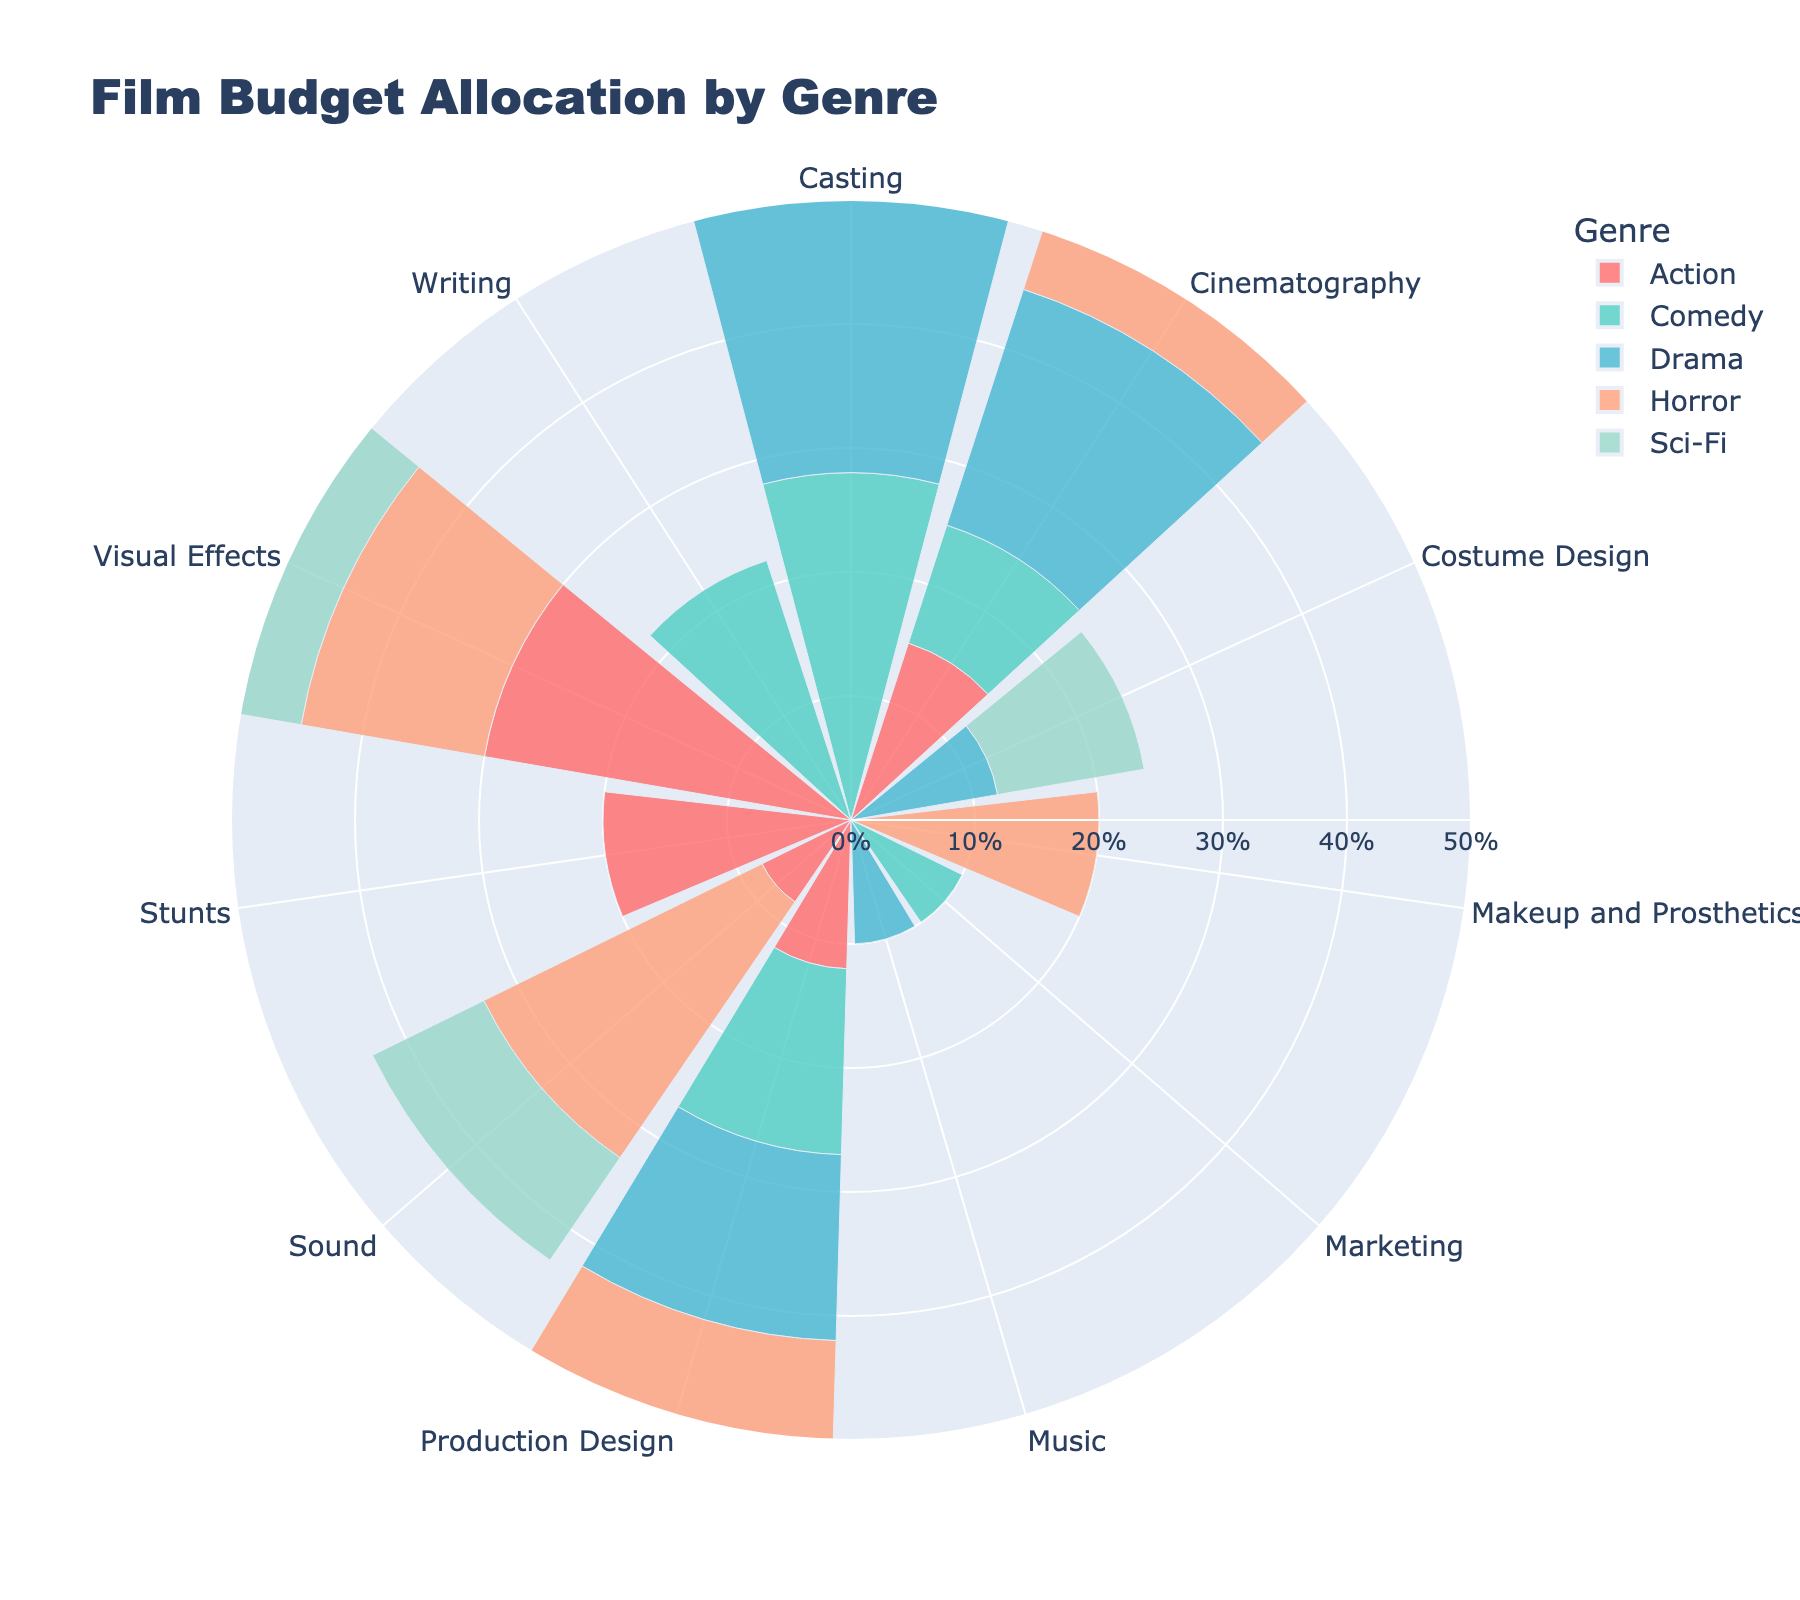What is the title of the plot? The title of the plot is located at the top and describes what the figure represents.
Answer: Film Budget Allocation by Genre How many genres are represented in the plot? The plot utilizes different colors and legends to represent distinct genres. By counting the number of unique legends, we can identify the number of genres.
Answer: 5 Which genre allocates the highest percentage to Visual Effects? The fan chart visually shows the proportion of each department's budget across genres. Find the longest bar in Visual Effects and check its genre via the legend.
Answer: Sci-Fi What is the combined budget percentage for Sound across all genres? To find the combined budget percentage, refer to the Sound department for each genre and sum up the values: Action (8) + Drama (0) + Comedy (0) + Sci-Fi (10) + Horror (25).
Answer: 43% Which genre has the highest percentage for Production Design? Compare the lengths of the bar for Production Design across all presented genres. The genre with the longest bar represents the highest percentage.
Answer: Sci-Fi How does the budget allocation for Cinematography differ between Action and Horror genres? Locate the Cinematography department in the fan chart and compare the lengths of the bars for the Action and Horror genres. Action allocates 15% while Horror allocates 18%.
Answer: Horror allocates 3% more than Action Which genre has the smallest budget percentage for Cinematography, and what is the value? Check the Cinematography section and identify the shortest bar, then refer to the legend for its genre.
Answer: Sci-Fi, 8% In which department does Drama allocate its highest budget percentage? Locate the Drama genre and check which department's bar reaches the highest proportion.
Answer: Casting Compare the budget allocation for Visual Effects between Action and Horror genres. Which one is greater and by how much? Locate the Visual Effects section and compare the lengths of the bars for Action and Horror. Action allocates 30% while Horror allocates 15%. The difference is 15%.
Answer: Action by 15% What is the average budget allocation percentage for Production Design across all genres? Sum the budget allocated to Production Design across genres and divide by the number of genres: (Action 12 + Drama 15 + Comedy 15 + Sci-Fi 20 + Horror 10) / 5.
Answer: 14.4% 